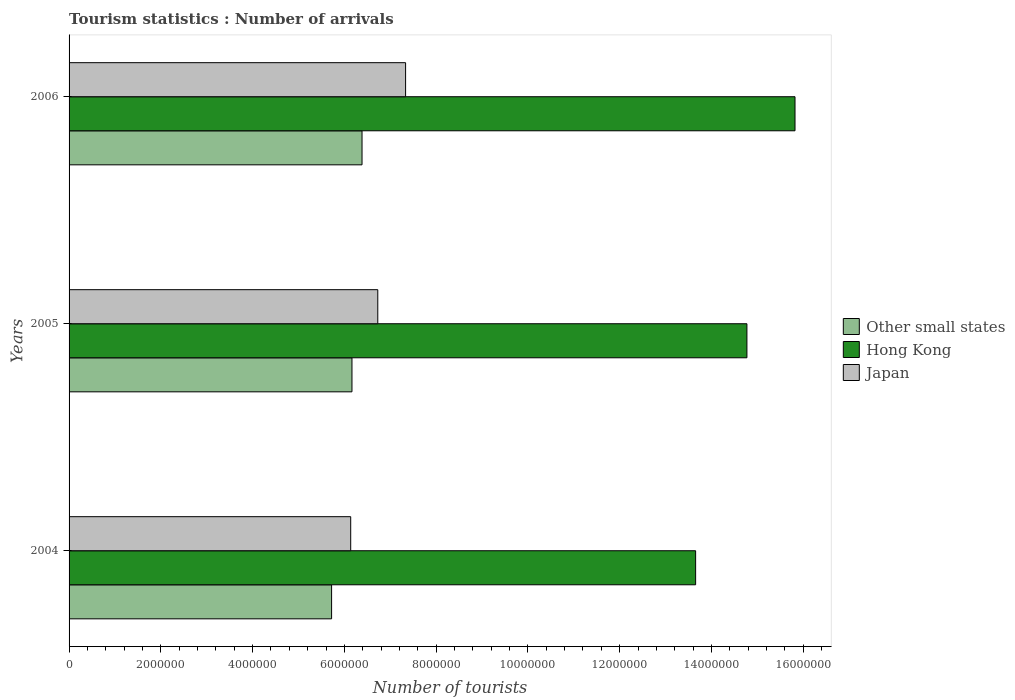How many different coloured bars are there?
Give a very brief answer. 3. Are the number of bars per tick equal to the number of legend labels?
Provide a succinct answer. Yes. Are the number of bars on each tick of the Y-axis equal?
Your answer should be compact. Yes. How many bars are there on the 3rd tick from the bottom?
Provide a short and direct response. 3. What is the number of tourist arrivals in Hong Kong in 2005?
Provide a succinct answer. 1.48e+07. Across all years, what is the maximum number of tourist arrivals in Hong Kong?
Offer a terse response. 1.58e+07. Across all years, what is the minimum number of tourist arrivals in Other small states?
Give a very brief answer. 5.72e+06. In which year was the number of tourist arrivals in Other small states maximum?
Ensure brevity in your answer.  2006. What is the total number of tourist arrivals in Japan in the graph?
Give a very brief answer. 2.02e+07. What is the difference between the number of tourist arrivals in Japan in 2004 and that in 2005?
Give a very brief answer. -5.90e+05. What is the difference between the number of tourist arrivals in Hong Kong in 2004 and the number of tourist arrivals in Other small states in 2006?
Provide a succinct answer. 7.27e+06. What is the average number of tourist arrivals in Other small states per year?
Your response must be concise. 6.09e+06. In the year 2005, what is the difference between the number of tourist arrivals in Other small states and number of tourist arrivals in Japan?
Provide a succinct answer. -5.63e+05. What is the ratio of the number of tourist arrivals in Hong Kong in 2005 to that in 2006?
Your answer should be very brief. 0.93. Is the difference between the number of tourist arrivals in Other small states in 2005 and 2006 greater than the difference between the number of tourist arrivals in Japan in 2005 and 2006?
Offer a very short reply. Yes. What is the difference between the highest and the second highest number of tourist arrivals in Other small states?
Your response must be concise. 2.20e+05. What is the difference between the highest and the lowest number of tourist arrivals in Other small states?
Make the answer very short. 6.64e+05. What does the 1st bar from the top in 2004 represents?
Your answer should be very brief. Japan. What does the 2nd bar from the bottom in 2004 represents?
Make the answer very short. Hong Kong. How many bars are there?
Your answer should be very brief. 9. Are all the bars in the graph horizontal?
Keep it short and to the point. Yes. What is the difference between two consecutive major ticks on the X-axis?
Give a very brief answer. 2.00e+06. Are the values on the major ticks of X-axis written in scientific E-notation?
Give a very brief answer. No. Where does the legend appear in the graph?
Keep it short and to the point. Center right. How many legend labels are there?
Your answer should be compact. 3. How are the legend labels stacked?
Give a very brief answer. Vertical. What is the title of the graph?
Make the answer very short. Tourism statistics : Number of arrivals. Does "Malaysia" appear as one of the legend labels in the graph?
Offer a very short reply. No. What is the label or title of the X-axis?
Your response must be concise. Number of tourists. What is the Number of tourists of Other small states in 2004?
Your answer should be compact. 5.72e+06. What is the Number of tourists in Hong Kong in 2004?
Make the answer very short. 1.37e+07. What is the Number of tourists of Japan in 2004?
Your answer should be very brief. 6.14e+06. What is the Number of tourists of Other small states in 2005?
Your response must be concise. 6.17e+06. What is the Number of tourists of Hong Kong in 2005?
Offer a very short reply. 1.48e+07. What is the Number of tourists in Japan in 2005?
Offer a terse response. 6.73e+06. What is the Number of tourists of Other small states in 2006?
Ensure brevity in your answer.  6.38e+06. What is the Number of tourists of Hong Kong in 2006?
Provide a short and direct response. 1.58e+07. What is the Number of tourists in Japan in 2006?
Make the answer very short. 7.33e+06. Across all years, what is the maximum Number of tourists in Other small states?
Ensure brevity in your answer.  6.38e+06. Across all years, what is the maximum Number of tourists of Hong Kong?
Your answer should be very brief. 1.58e+07. Across all years, what is the maximum Number of tourists of Japan?
Provide a succinct answer. 7.33e+06. Across all years, what is the minimum Number of tourists in Other small states?
Offer a terse response. 5.72e+06. Across all years, what is the minimum Number of tourists in Hong Kong?
Keep it short and to the point. 1.37e+07. Across all years, what is the minimum Number of tourists in Japan?
Your answer should be very brief. 6.14e+06. What is the total Number of tourists in Other small states in the graph?
Keep it short and to the point. 1.83e+07. What is the total Number of tourists of Hong Kong in the graph?
Keep it short and to the point. 4.42e+07. What is the total Number of tourists of Japan in the graph?
Give a very brief answer. 2.02e+07. What is the difference between the Number of tourists of Other small states in 2004 and that in 2005?
Give a very brief answer. -4.44e+05. What is the difference between the Number of tourists in Hong Kong in 2004 and that in 2005?
Your answer should be compact. -1.12e+06. What is the difference between the Number of tourists in Japan in 2004 and that in 2005?
Your response must be concise. -5.90e+05. What is the difference between the Number of tourists in Other small states in 2004 and that in 2006?
Offer a very short reply. -6.64e+05. What is the difference between the Number of tourists of Hong Kong in 2004 and that in 2006?
Provide a short and direct response. -2.17e+06. What is the difference between the Number of tourists of Japan in 2004 and that in 2006?
Provide a short and direct response. -1.20e+06. What is the difference between the Number of tourists of Other small states in 2005 and that in 2006?
Offer a very short reply. -2.20e+05. What is the difference between the Number of tourists in Hong Kong in 2005 and that in 2006?
Give a very brief answer. -1.05e+06. What is the difference between the Number of tourists in Japan in 2005 and that in 2006?
Your response must be concise. -6.06e+05. What is the difference between the Number of tourists in Other small states in 2004 and the Number of tourists in Hong Kong in 2005?
Keep it short and to the point. -9.05e+06. What is the difference between the Number of tourists in Other small states in 2004 and the Number of tourists in Japan in 2005?
Offer a terse response. -1.01e+06. What is the difference between the Number of tourists of Hong Kong in 2004 and the Number of tourists of Japan in 2005?
Provide a short and direct response. 6.93e+06. What is the difference between the Number of tourists in Other small states in 2004 and the Number of tourists in Hong Kong in 2006?
Make the answer very short. -1.01e+07. What is the difference between the Number of tourists of Other small states in 2004 and the Number of tourists of Japan in 2006?
Your response must be concise. -1.61e+06. What is the difference between the Number of tourists of Hong Kong in 2004 and the Number of tourists of Japan in 2006?
Offer a terse response. 6.32e+06. What is the difference between the Number of tourists in Other small states in 2005 and the Number of tourists in Hong Kong in 2006?
Provide a succinct answer. -9.66e+06. What is the difference between the Number of tourists in Other small states in 2005 and the Number of tourists in Japan in 2006?
Provide a succinct answer. -1.17e+06. What is the difference between the Number of tourists of Hong Kong in 2005 and the Number of tourists of Japan in 2006?
Keep it short and to the point. 7.44e+06. What is the average Number of tourists in Other small states per year?
Offer a very short reply. 6.09e+06. What is the average Number of tourists of Hong Kong per year?
Make the answer very short. 1.47e+07. What is the average Number of tourists in Japan per year?
Give a very brief answer. 6.73e+06. In the year 2004, what is the difference between the Number of tourists of Other small states and Number of tourists of Hong Kong?
Keep it short and to the point. -7.93e+06. In the year 2004, what is the difference between the Number of tourists of Other small states and Number of tourists of Japan?
Give a very brief answer. -4.17e+05. In the year 2004, what is the difference between the Number of tourists of Hong Kong and Number of tourists of Japan?
Offer a very short reply. 7.52e+06. In the year 2005, what is the difference between the Number of tourists in Other small states and Number of tourists in Hong Kong?
Your answer should be compact. -8.61e+06. In the year 2005, what is the difference between the Number of tourists in Other small states and Number of tourists in Japan?
Your answer should be very brief. -5.63e+05. In the year 2005, what is the difference between the Number of tourists in Hong Kong and Number of tourists in Japan?
Keep it short and to the point. 8.04e+06. In the year 2006, what is the difference between the Number of tourists in Other small states and Number of tourists in Hong Kong?
Your answer should be very brief. -9.44e+06. In the year 2006, what is the difference between the Number of tourists of Other small states and Number of tourists of Japan?
Give a very brief answer. -9.49e+05. In the year 2006, what is the difference between the Number of tourists in Hong Kong and Number of tourists in Japan?
Offer a terse response. 8.49e+06. What is the ratio of the Number of tourists of Other small states in 2004 to that in 2005?
Provide a succinct answer. 0.93. What is the ratio of the Number of tourists of Hong Kong in 2004 to that in 2005?
Give a very brief answer. 0.92. What is the ratio of the Number of tourists in Japan in 2004 to that in 2005?
Give a very brief answer. 0.91. What is the ratio of the Number of tourists of Other small states in 2004 to that in 2006?
Keep it short and to the point. 0.9. What is the ratio of the Number of tourists of Hong Kong in 2004 to that in 2006?
Your answer should be very brief. 0.86. What is the ratio of the Number of tourists in Japan in 2004 to that in 2006?
Provide a succinct answer. 0.84. What is the ratio of the Number of tourists of Other small states in 2005 to that in 2006?
Offer a very short reply. 0.97. What is the ratio of the Number of tourists of Hong Kong in 2005 to that in 2006?
Make the answer very short. 0.93. What is the ratio of the Number of tourists of Japan in 2005 to that in 2006?
Ensure brevity in your answer.  0.92. What is the difference between the highest and the second highest Number of tourists in Other small states?
Provide a succinct answer. 2.20e+05. What is the difference between the highest and the second highest Number of tourists of Hong Kong?
Offer a very short reply. 1.05e+06. What is the difference between the highest and the second highest Number of tourists in Japan?
Offer a very short reply. 6.06e+05. What is the difference between the highest and the lowest Number of tourists in Other small states?
Make the answer very short. 6.64e+05. What is the difference between the highest and the lowest Number of tourists of Hong Kong?
Give a very brief answer. 2.17e+06. What is the difference between the highest and the lowest Number of tourists in Japan?
Give a very brief answer. 1.20e+06. 